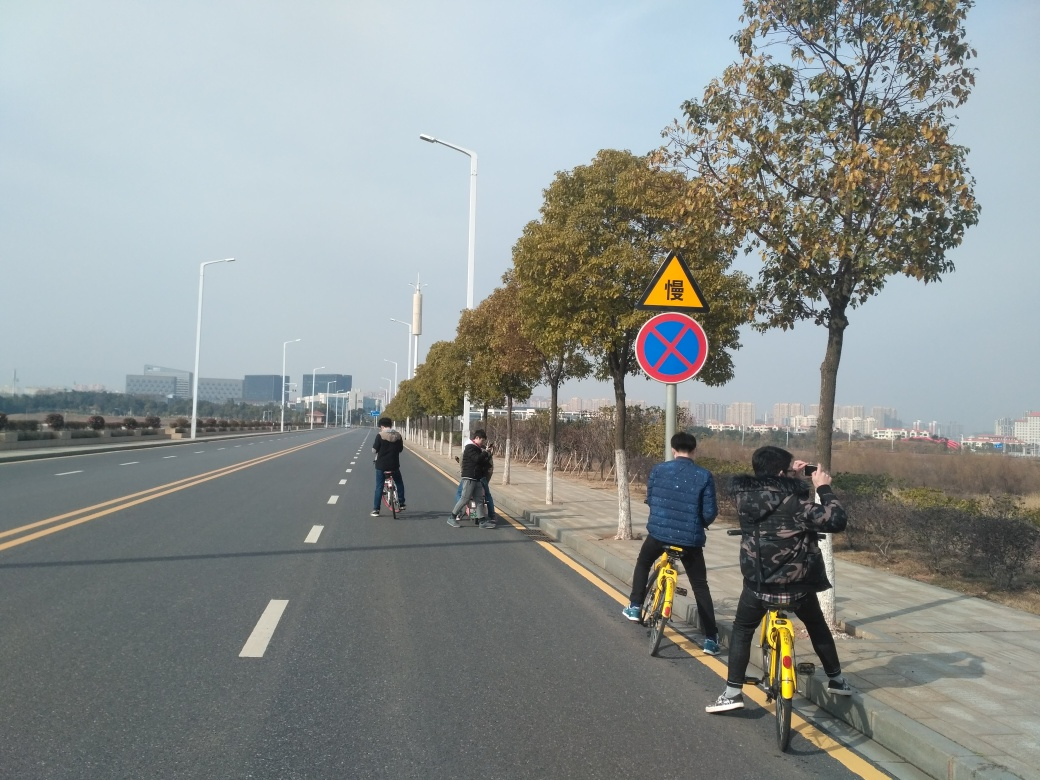Is there any blurriness in the image?
A. Yes
B. No
Answer with the option's letter from the given choices directly.
 B. 